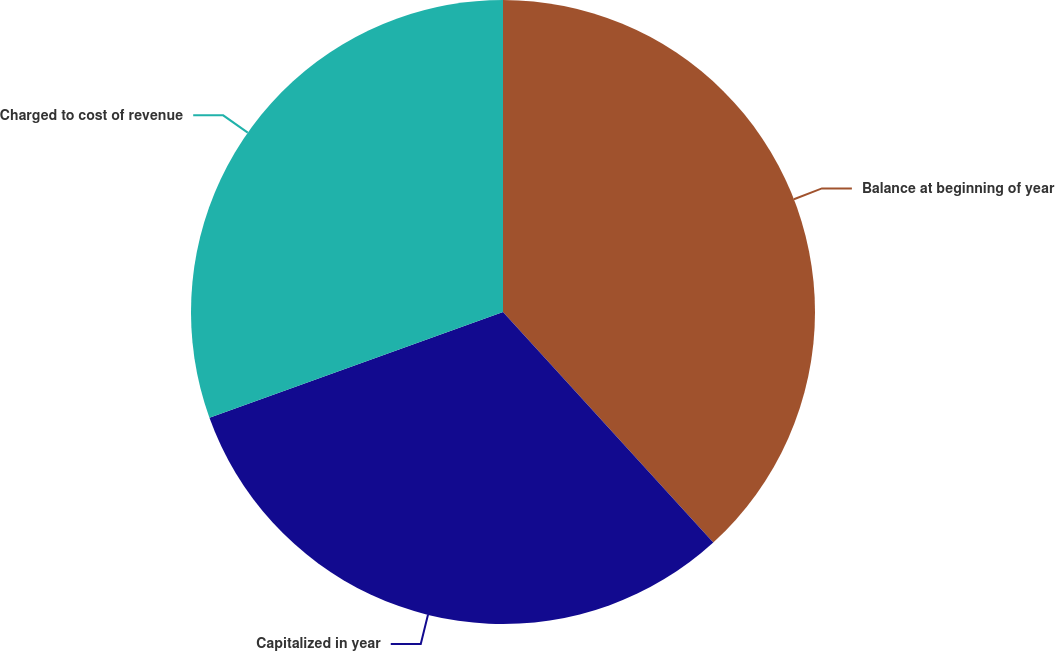Convert chart to OTSL. <chart><loc_0><loc_0><loc_500><loc_500><pie_chart><fcel>Balance at beginning of year<fcel>Capitalized in year<fcel>Charged to cost of revenue<nl><fcel>38.23%<fcel>31.27%<fcel>30.5%<nl></chart> 